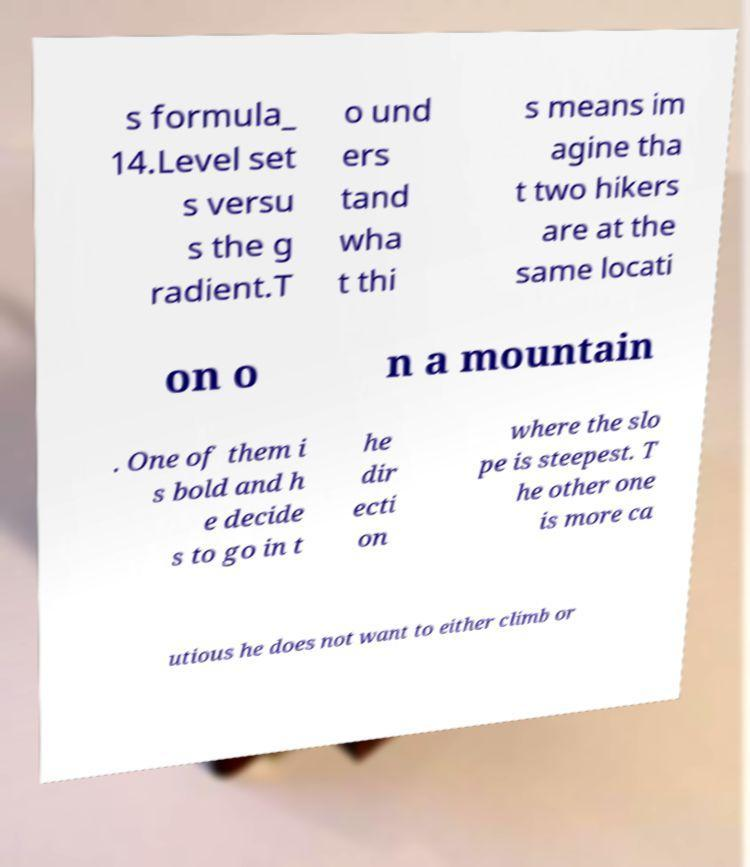Could you assist in decoding the text presented in this image and type it out clearly? s formula_ 14.Level set s versu s the g radient.T o und ers tand wha t thi s means im agine tha t two hikers are at the same locati on o n a mountain . One of them i s bold and h e decide s to go in t he dir ecti on where the slo pe is steepest. T he other one is more ca utious he does not want to either climb or 